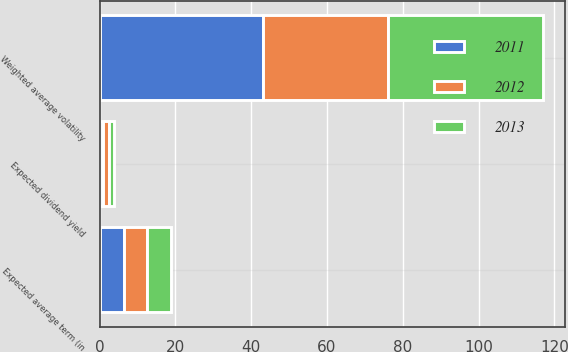Convert chart to OTSL. <chart><loc_0><loc_0><loc_500><loc_500><stacked_bar_chart><ecel><fcel>Expected average term (in<fcel>Weighted average volatility<fcel>Expected dividend yield<nl><fcel>2012<fcel>6.1<fcel>33<fcel>1.6<nl><fcel>2013<fcel>6.3<fcel>41<fcel>1.1<nl><fcel>2011<fcel>6.5<fcel>43<fcel>1<nl></chart> 